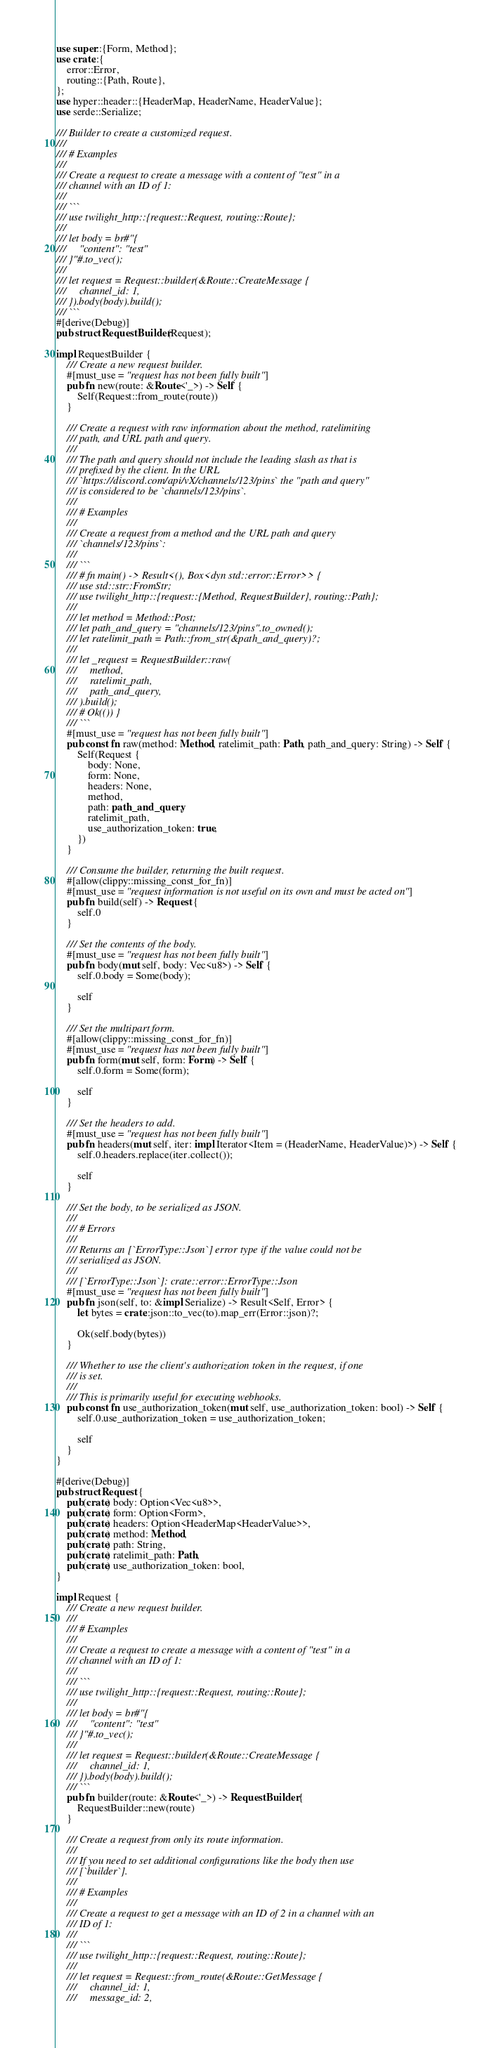Convert code to text. <code><loc_0><loc_0><loc_500><loc_500><_Rust_>use super::{Form, Method};
use crate::{
    error::Error,
    routing::{Path, Route},
};
use hyper::header::{HeaderMap, HeaderName, HeaderValue};
use serde::Serialize;

/// Builder to create a customized request.
///
/// # Examples
///
/// Create a request to create a message with a content of "test" in a
/// channel with an ID of 1:
///
/// ```
/// use twilight_http::{request::Request, routing::Route};
///
/// let body = br#"{
///     "content": "test"
/// }"#.to_vec();
///
/// let request = Request::builder(&Route::CreateMessage {
///     channel_id: 1,
/// }).body(body).build();
/// ```
#[derive(Debug)]
pub struct RequestBuilder(Request);

impl RequestBuilder {
    /// Create a new request builder.
    #[must_use = "request has not been fully built"]
    pub fn new(route: &Route<'_>) -> Self {
        Self(Request::from_route(route))
    }

    /// Create a request with raw information about the method, ratelimiting
    /// path, and URL path and query.
    ///
    /// The path and query should not include the leading slash as that is
    /// prefixed by the client. In the URL
    /// `https://discord.com/api/vX/channels/123/pins` the "path and query"
    /// is considered to be `channels/123/pins`.
    ///
    /// # Examples
    ///
    /// Create a request from a method and the URL path and query
    /// `channels/123/pins`:
    ///
    /// ```
    /// # fn main() -> Result<(), Box<dyn std::error::Error>> {
    /// use std::str::FromStr;
    /// use twilight_http::{request::{Method, RequestBuilder}, routing::Path};
    ///
    /// let method = Method::Post;
    /// let path_and_query = "channels/123/pins".to_owned();
    /// let ratelimit_path = Path::from_str(&path_and_query)?;
    ///
    /// let _request = RequestBuilder::raw(
    ///     method,
    ///     ratelimit_path,
    ///     path_and_query,
    /// ).build();
    /// # Ok(()) }
    /// ```
    #[must_use = "request has not been fully built"]
    pub const fn raw(method: Method, ratelimit_path: Path, path_and_query: String) -> Self {
        Self(Request {
            body: None,
            form: None,
            headers: None,
            method,
            path: path_and_query,
            ratelimit_path,
            use_authorization_token: true,
        })
    }

    /// Consume the builder, returning the built request.
    #[allow(clippy::missing_const_for_fn)]
    #[must_use = "request information is not useful on its own and must be acted on"]
    pub fn build(self) -> Request {
        self.0
    }

    /// Set the contents of the body.
    #[must_use = "request has not been fully built"]
    pub fn body(mut self, body: Vec<u8>) -> Self {
        self.0.body = Some(body);

        self
    }

    /// Set the multipart form.
    #[allow(clippy::missing_const_for_fn)]
    #[must_use = "request has not been fully built"]
    pub fn form(mut self, form: Form) -> Self {
        self.0.form = Some(form);

        self
    }

    /// Set the headers to add.
    #[must_use = "request has not been fully built"]
    pub fn headers(mut self, iter: impl Iterator<Item = (HeaderName, HeaderValue)>) -> Self {
        self.0.headers.replace(iter.collect());

        self
    }

    /// Set the body, to be serialized as JSON.
    ///
    /// # Errors
    ///
    /// Returns an [`ErrorType::Json`] error type if the value could not be
    /// serialized as JSON.
    ///
    /// [`ErrorType::Json`]: crate::error::ErrorType::Json
    #[must_use = "request has not been fully built"]
    pub fn json(self, to: &impl Serialize) -> Result<Self, Error> {
        let bytes = crate::json::to_vec(to).map_err(Error::json)?;

        Ok(self.body(bytes))
    }

    /// Whether to use the client's authorization token in the request, if one
    /// is set.
    ///
    /// This is primarily useful for executing webhooks.
    pub const fn use_authorization_token(mut self, use_authorization_token: bool) -> Self {
        self.0.use_authorization_token = use_authorization_token;

        self
    }
}

#[derive(Debug)]
pub struct Request {
    pub(crate) body: Option<Vec<u8>>,
    pub(crate) form: Option<Form>,
    pub(crate) headers: Option<HeaderMap<HeaderValue>>,
    pub(crate) method: Method,
    pub(crate) path: String,
    pub(crate) ratelimit_path: Path,
    pub(crate) use_authorization_token: bool,
}

impl Request {
    /// Create a new request builder.
    ///
    /// # Examples
    ///
    /// Create a request to create a message with a content of "test" in a
    /// channel with an ID of 1:
    ///
    /// ```
    /// use twilight_http::{request::Request, routing::Route};
    ///
    /// let body = br#"{
    ///     "content": "test"
    /// }"#.to_vec();
    ///
    /// let request = Request::builder(&Route::CreateMessage {
    ///     channel_id: 1,
    /// }).body(body).build();
    /// ```
    pub fn builder(route: &Route<'_>) -> RequestBuilder {
        RequestBuilder::new(route)
    }

    /// Create a request from only its route information.
    ///
    /// If you need to set additional configurations like the body then use
    /// [`builder`].
    ///
    /// # Examples
    ///
    /// Create a request to get a message with an ID of 2 in a channel with an
    /// ID of 1:
    ///
    /// ```
    /// use twilight_http::{request::Request, routing::Route};
    ///
    /// let request = Request::from_route(&Route::GetMessage {
    ///     channel_id: 1,
    ///     message_id: 2,</code> 